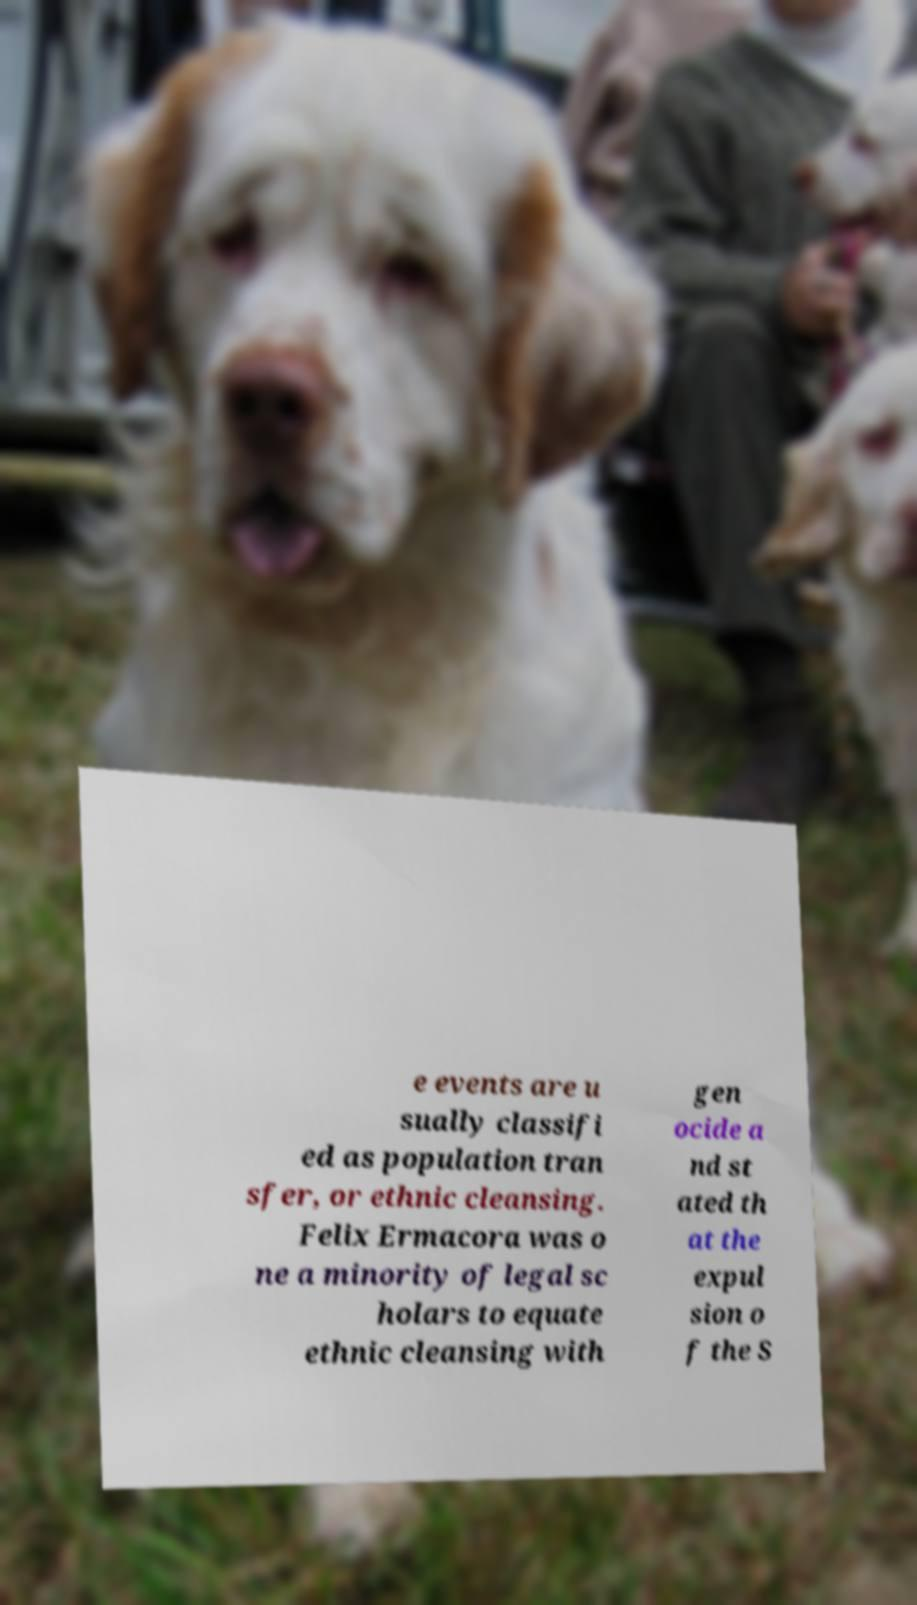There's text embedded in this image that I need extracted. Can you transcribe it verbatim? e events are u sually classifi ed as population tran sfer, or ethnic cleansing. Felix Ermacora was o ne a minority of legal sc holars to equate ethnic cleansing with gen ocide a nd st ated th at the expul sion o f the S 